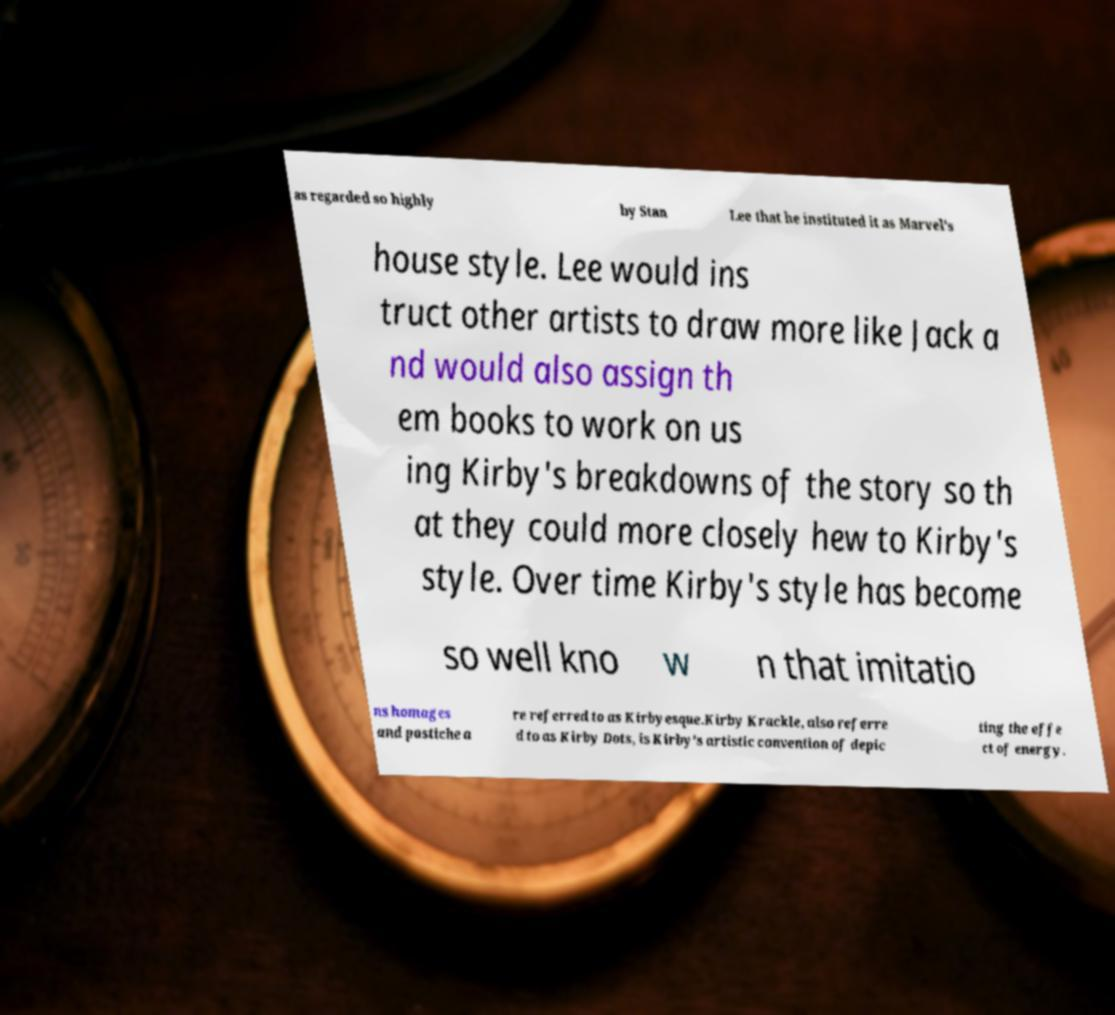For documentation purposes, I need the text within this image transcribed. Could you provide that? as regarded so highly by Stan Lee that he instituted it as Marvel's house style. Lee would ins truct other artists to draw more like Jack a nd would also assign th em books to work on us ing Kirby's breakdowns of the story so th at they could more closely hew to Kirby's style. Over time Kirby's style has become so well kno w n that imitatio ns homages and pastiche a re referred to as Kirbyesque.Kirby Krackle, also referre d to as Kirby Dots, is Kirby's artistic convention of depic ting the effe ct of energy. 